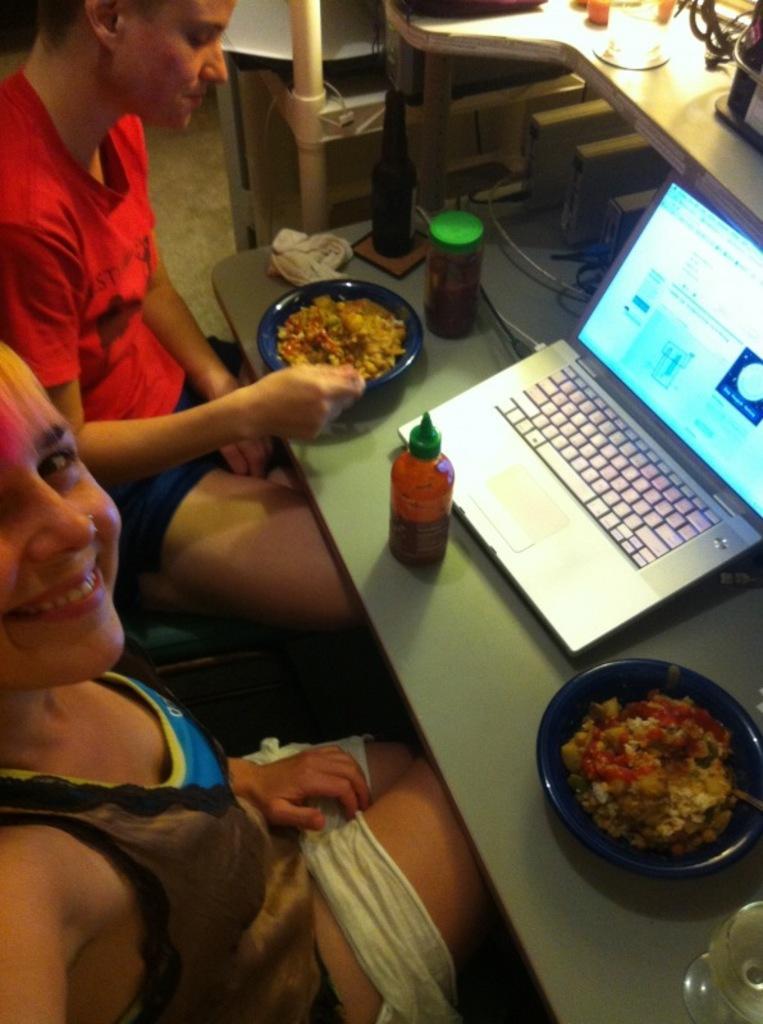How would you summarize this image in a sentence or two? In this picture, we see a man and a woman are sitting on the chairs. We see a woman is smiling and she is posing for the photo. In front of them, we see a table on which two bowls containing the food and spoons are placed. We see a glass bottle, a box with a green lid, glass tissue papers, sauce bottle, laptop and the cables are placed on the table. In the right top, we see a table on which the cables and the objects are placed. 